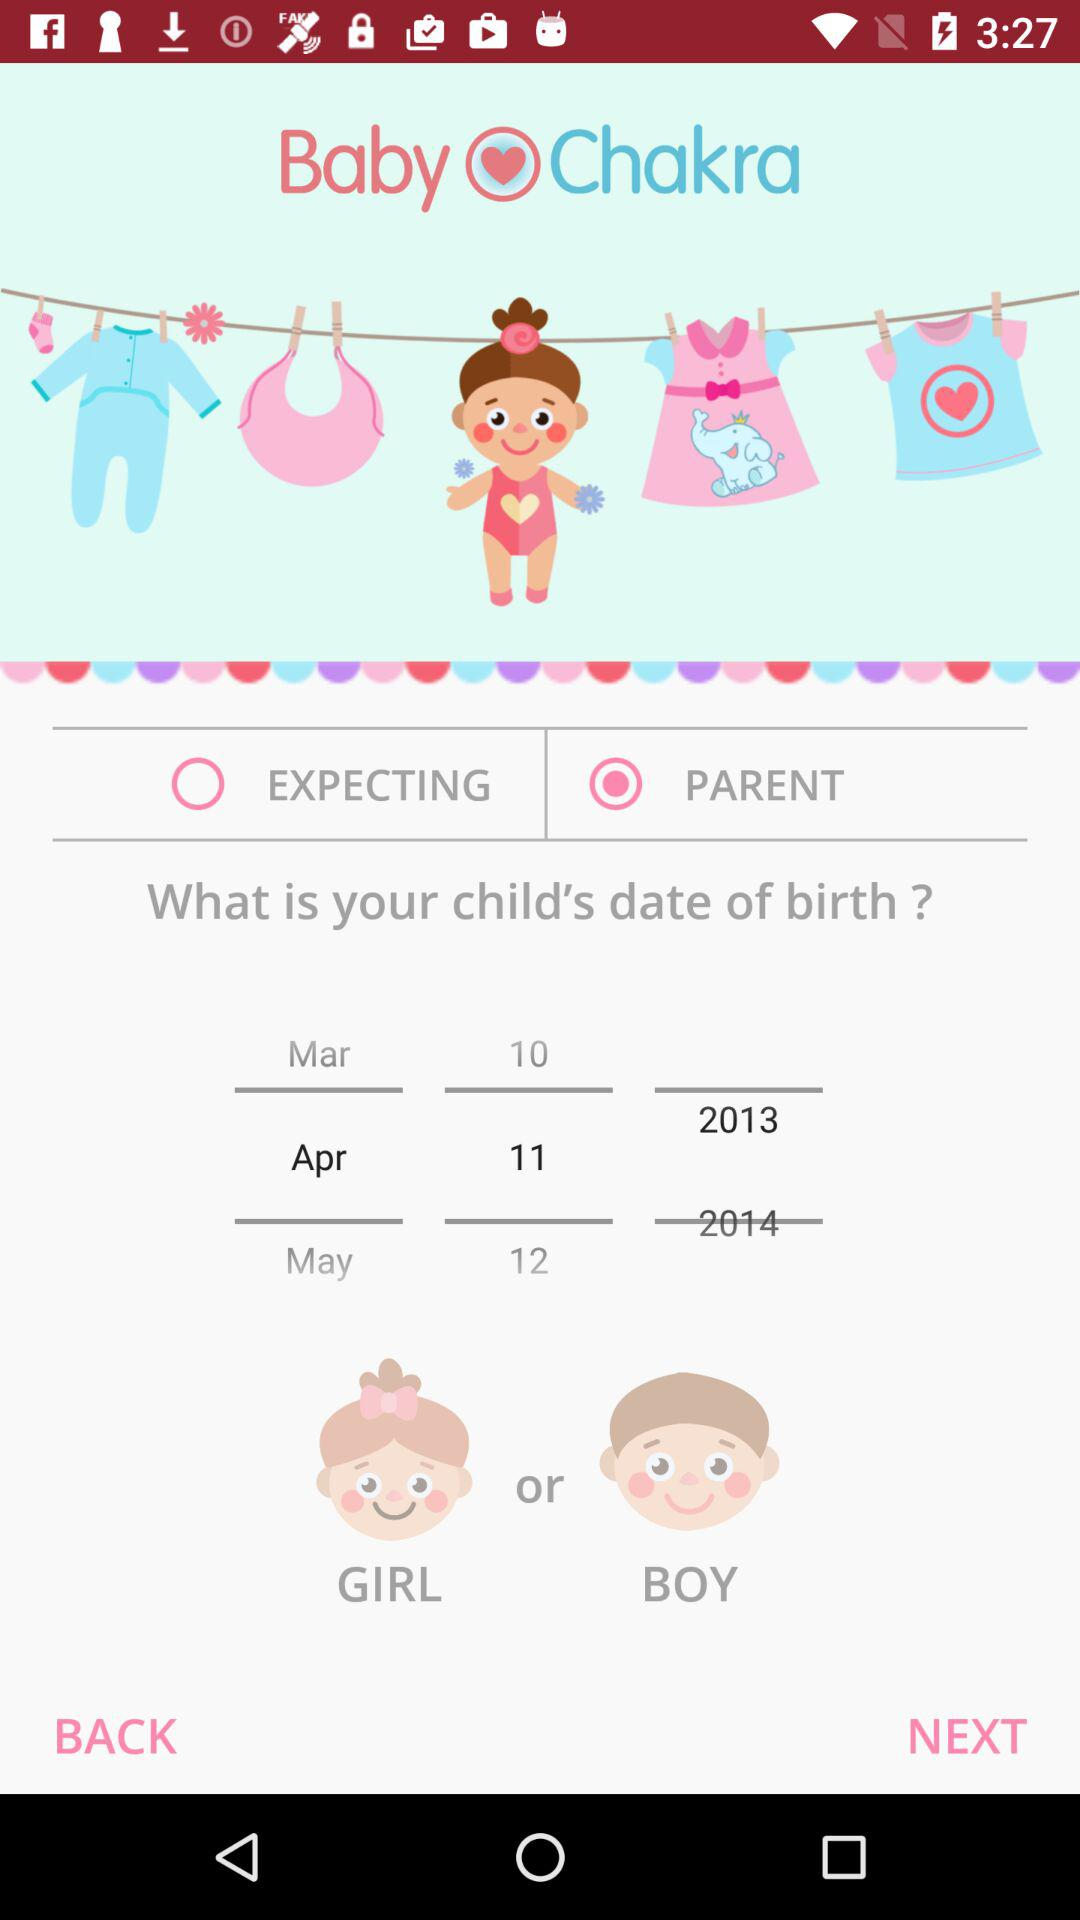How many years are between the earliest and latest birth dates?
Answer the question using a single word or phrase. 1 